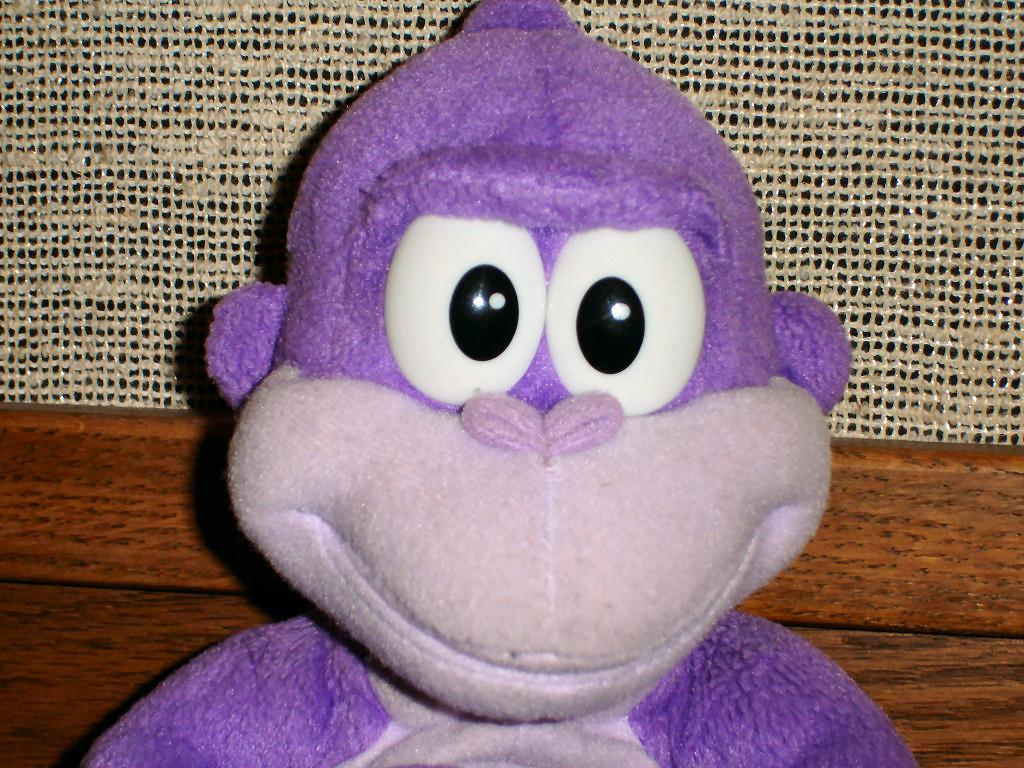How would you summarize this image in a sentence or two? In this image we can see a soft toy and there is a wooden block. There is a jute cloth. 